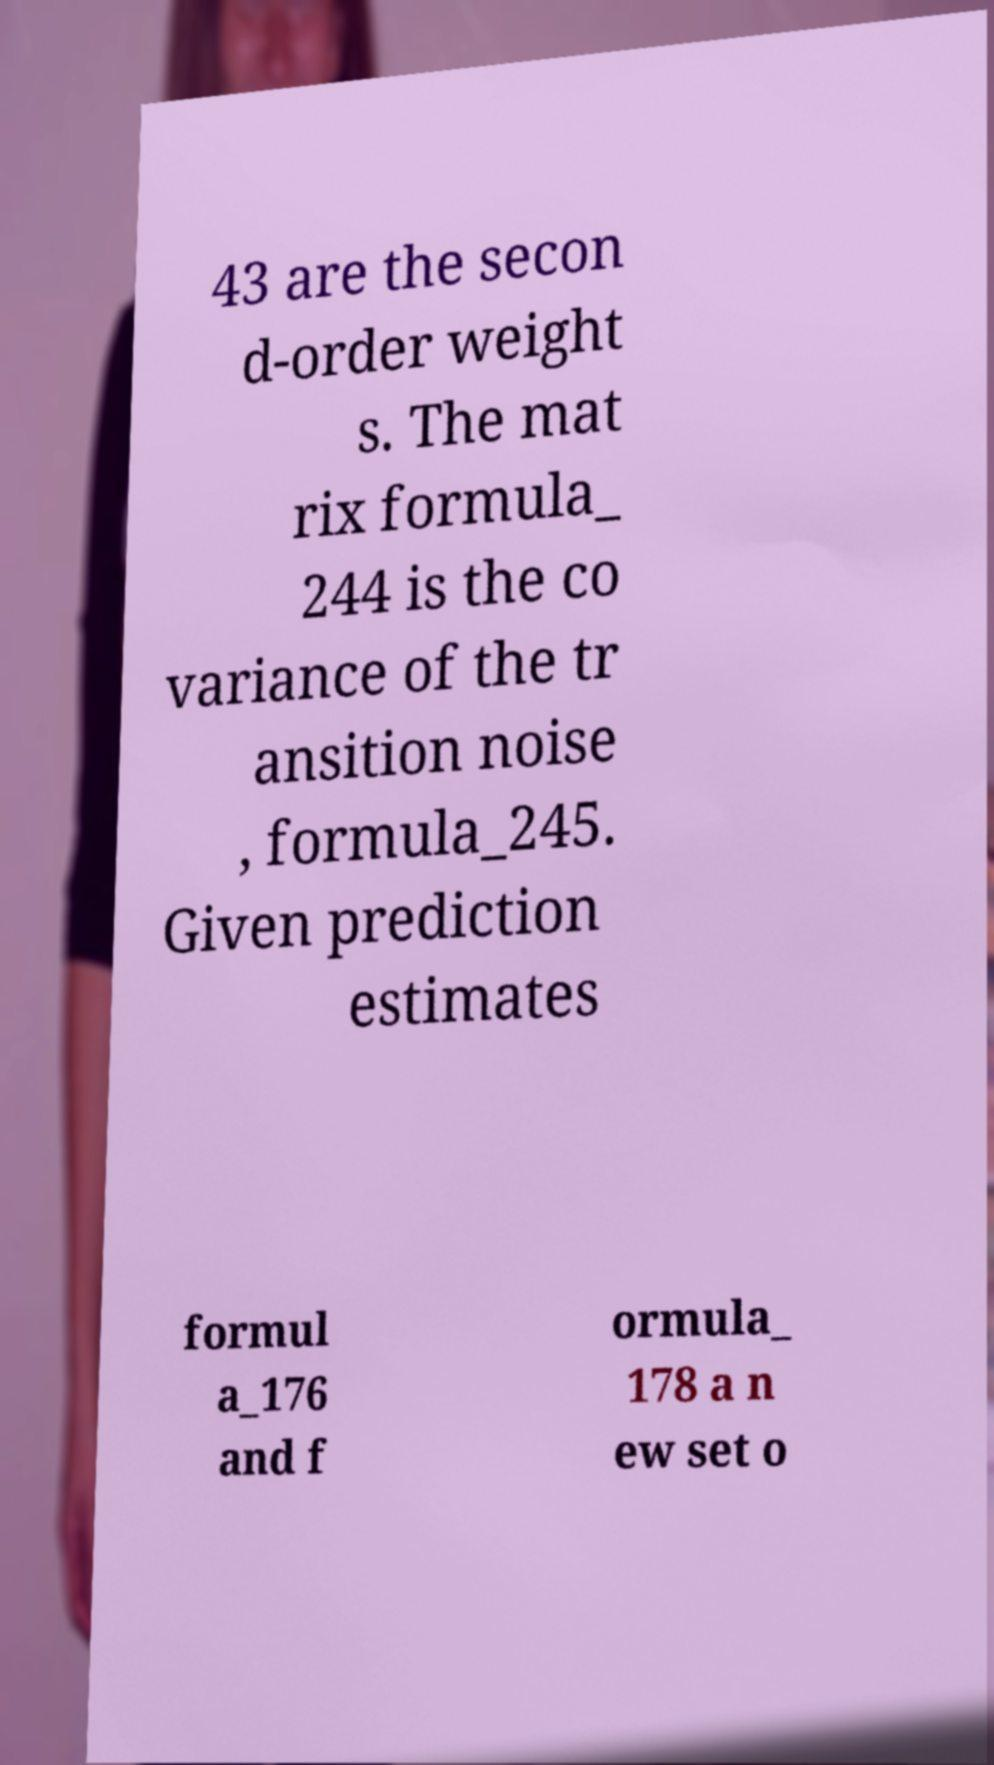There's text embedded in this image that I need extracted. Can you transcribe it verbatim? 43 are the secon d-order weight s. The mat rix formula_ 244 is the co variance of the tr ansition noise , formula_245. Given prediction estimates formul a_176 and f ormula_ 178 a n ew set o 